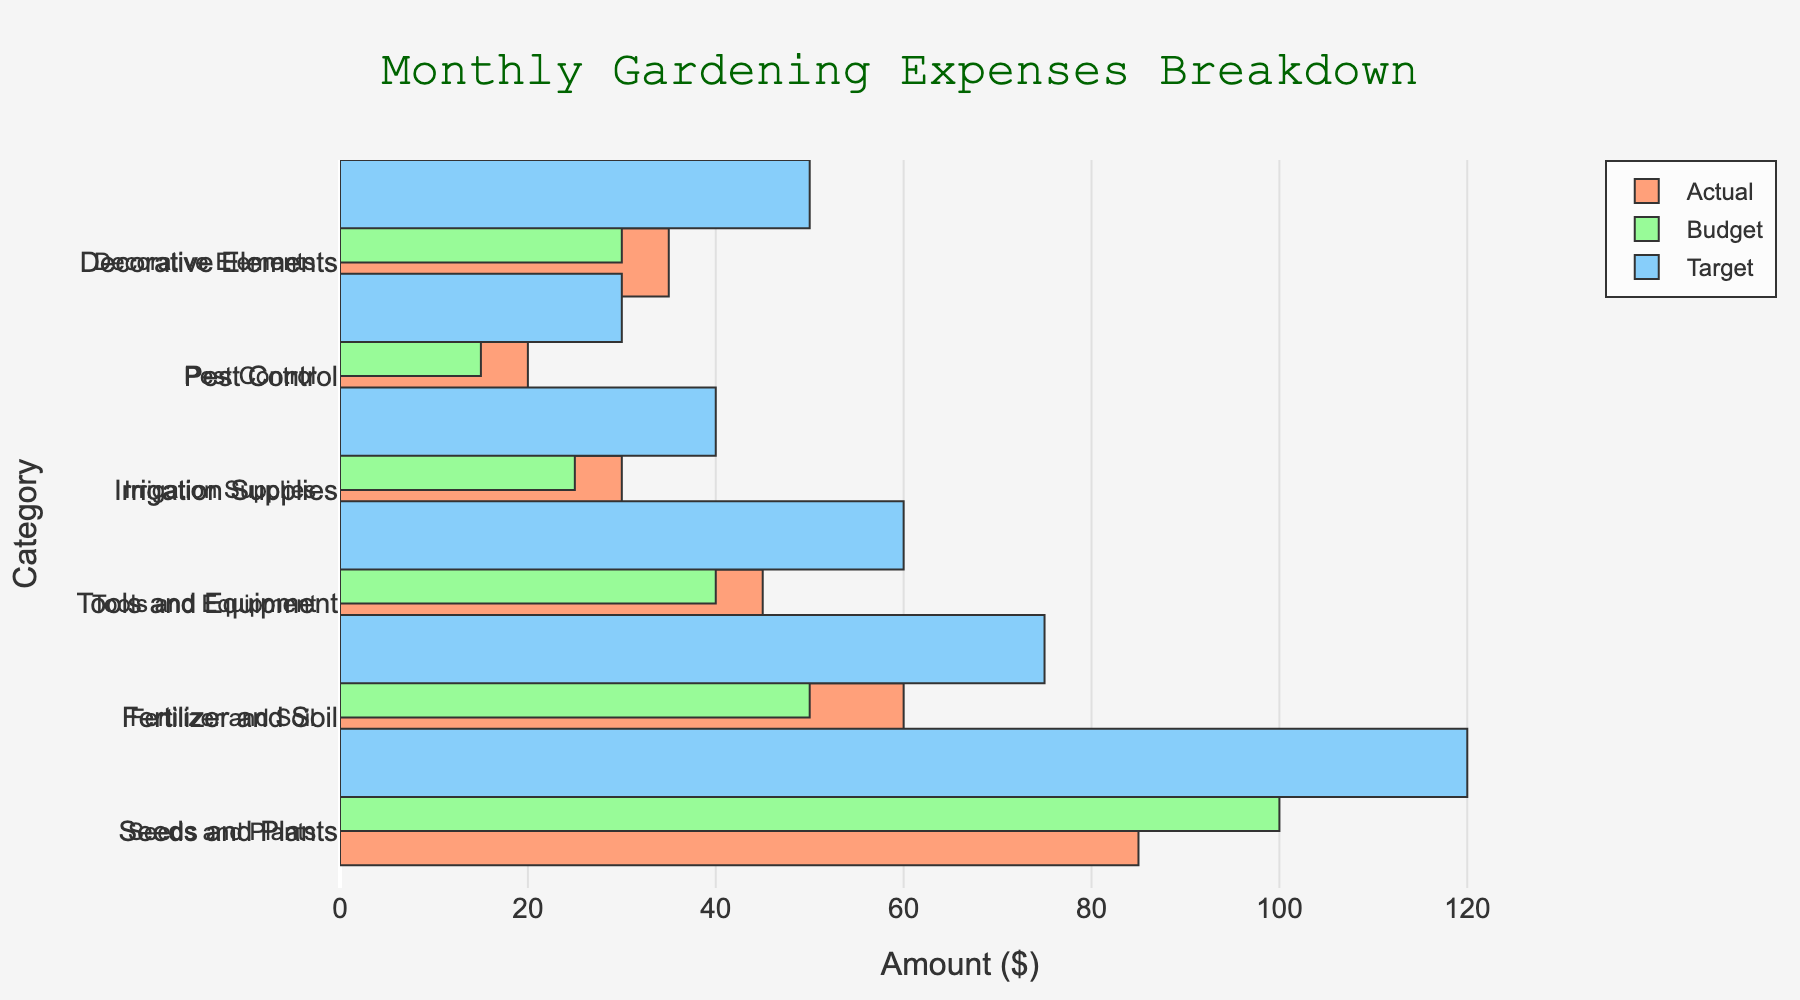How many categories of gardening expenses are represented in the figure? Count the number of distinct categories along the y-axis, which are 'Seeds and Plants', 'Fertilizer and Soil', 'Tools and Equipment', 'Irrigation Supplies', 'Pest Control', and 'Decorative Elements'.
Answer: 6 What's the total actual spending on 'Fertilizer and Soil' and 'Pest Control'? Add the actual expenses for 'Fertilizer and Soil' ($60) and 'Pest Control' ($20).
Answer: $80 Which category has the highest difference between actual spending and the budget? Compute the differences: 'Seeds and Plants' ($100 - $85 = $15), 'Fertilizer and Soil' ($50 - $60 = -$10), 'Tools and Equipment' ($40 - $45 = -$5), 'Irrigation Supplies' ($25 - $30 = -$5), 'Pest Control' ($15 - $20 = -$5), 'Decorative Elements' ($30 - $35 = -$5). The highest positive difference is for 'Seeds and Plants'.
Answer: Seeds and Plants Is the actual spending on 'Irrigation Supplies' greater than the budget for 'Pest Control'? Compare the actual spending on 'Irrigation Supplies' ($30) to the budget for 'Pest Control' ($15).
Answer: Yes Which category met its budget most closely? Calculate the absolute differences: 'Seeds and Plants' ($85 - $100 = $15), 'Fertilizer and Soil' ($60 - $50 = $10), 'Tools and Equipment' ($45 - $40 = $5), 'Irrigation Supplies' ($30 - $25 = $5), 'Pest Control' ($20 - $15 = $5), 'Decorative Elements' ($35 - $30 = $5). The smallest difference is $5, but since multiple categories have this difference ('Tools and Equipment', 'Irrigation Supplies', 'Pest Control', 'Decorative Elements'), you need to specify which.
Answer: Tools and Equipment, Irrigation Supplies, Pest Control, Decorative Elements What is the target expense for 'Seeds and Plants'? Identify the target value for 'Seeds and Plants' from the figure.
Answer: $120 